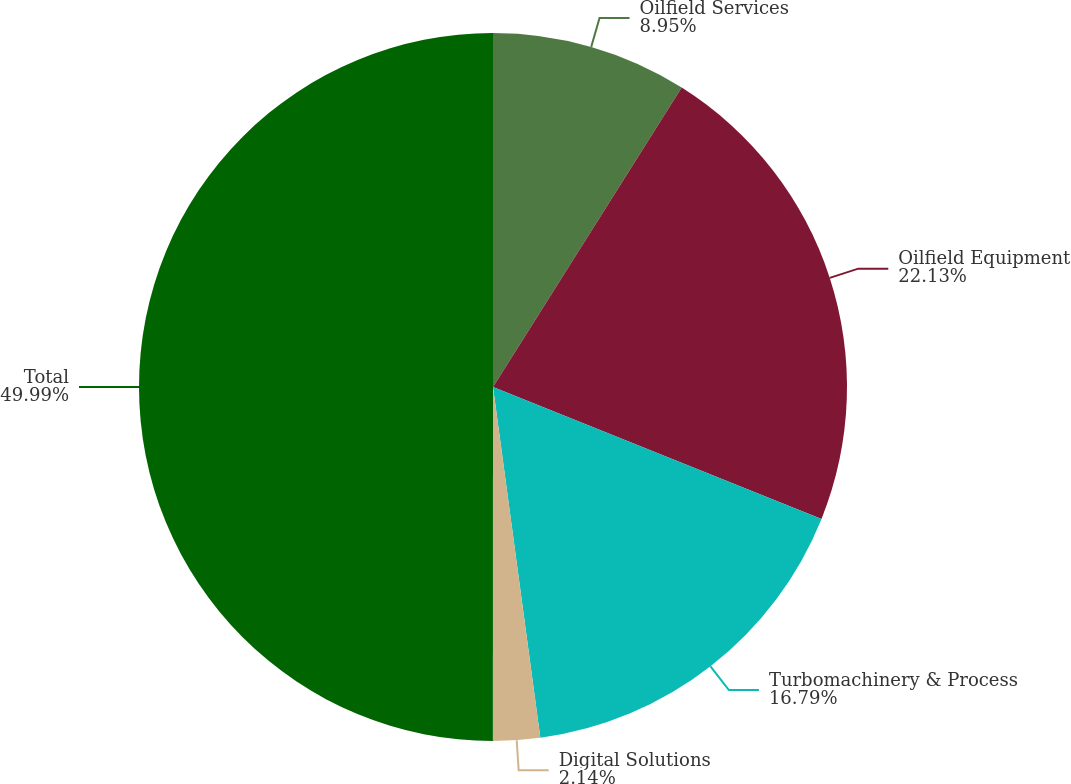Convert chart. <chart><loc_0><loc_0><loc_500><loc_500><pie_chart><fcel>Oilfield Services<fcel>Oilfield Equipment<fcel>Turbomachinery & Process<fcel>Digital Solutions<fcel>Total<nl><fcel>8.95%<fcel>22.13%<fcel>16.79%<fcel>2.14%<fcel>50.0%<nl></chart> 